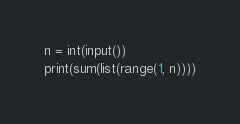<code> <loc_0><loc_0><loc_500><loc_500><_Python_>n = int(input())
print(sum(list(range(1, n))))</code> 